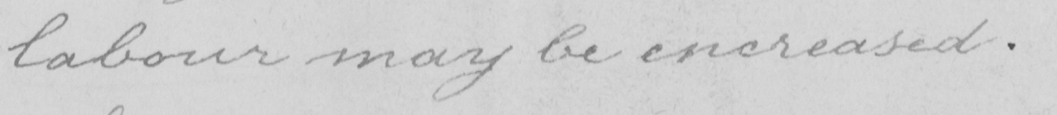What is written in this line of handwriting? labour may be encreased . 